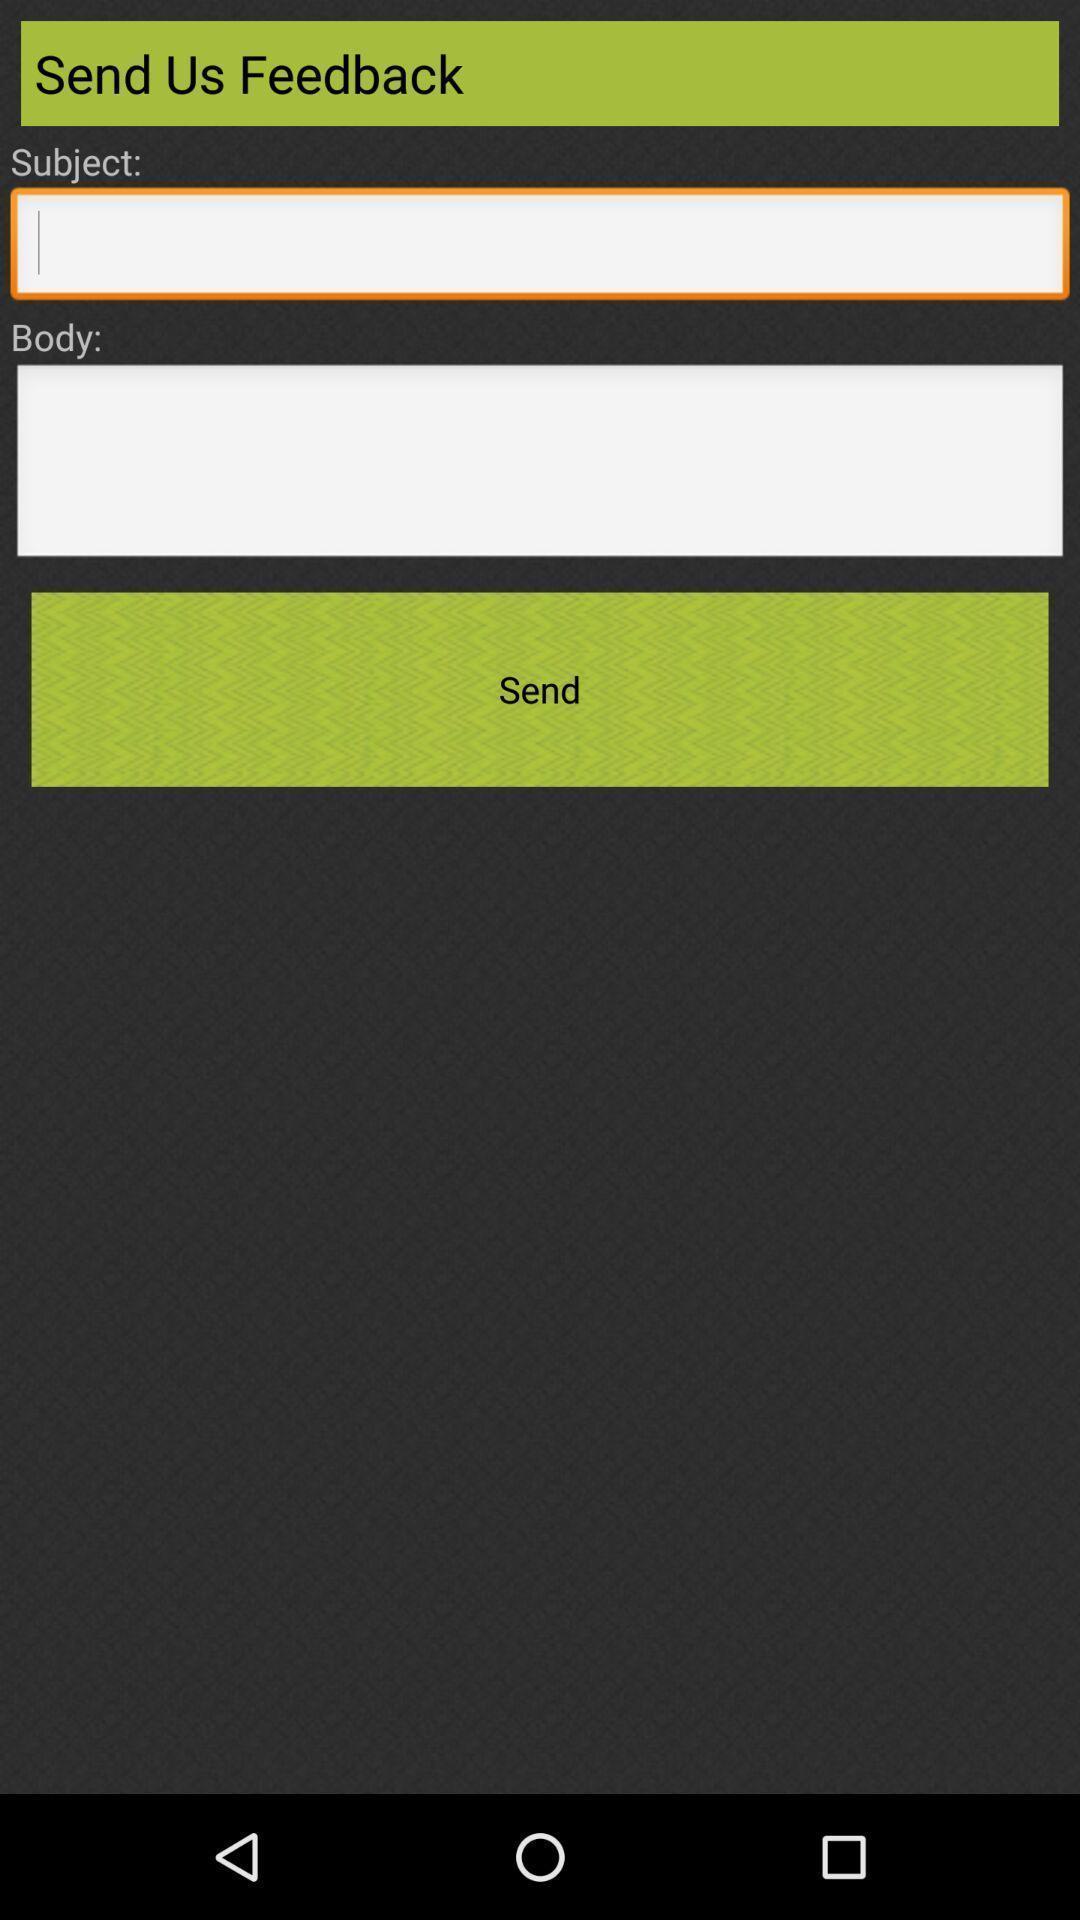Explain the elements present in this screenshot. Page to send a feedback of the application. 